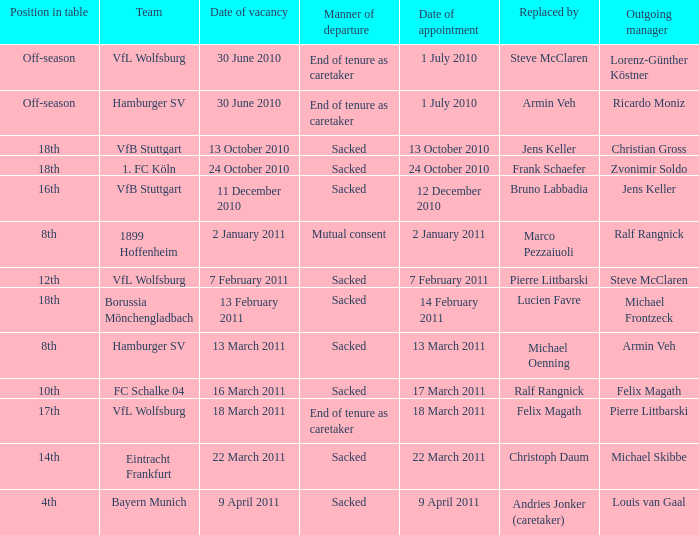When steve mcclaren is the replacer what is the manner of departure? End of tenure as caretaker. 